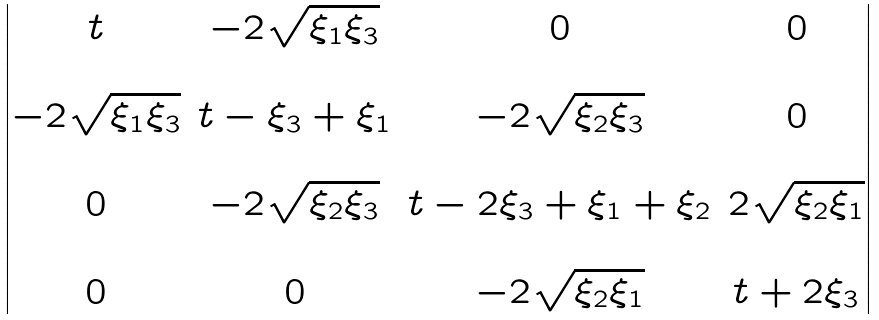<formula> <loc_0><loc_0><loc_500><loc_500>\begin{vmatrix} t & - 2 \sqrt { \xi _ { 1 } \xi _ { 3 } } & 0 & 0 \\ & & & \\ - 2 \sqrt { \xi _ { 1 } \xi _ { 3 } } & t - \xi _ { 3 } + \xi _ { 1 } & - 2 \sqrt { \xi _ { 2 } \xi _ { 3 } } & 0 \\ & & & \\ 0 & - 2 \sqrt { \xi _ { 2 } \xi _ { 3 } } & t - 2 \xi _ { 3 } + \xi _ { 1 } + \xi _ { 2 } & 2 \sqrt { \xi _ { 2 } \xi _ { 1 } } \\ & & & \\ 0 & 0 & - 2 \sqrt { \xi _ { 2 } \xi _ { 1 } } & t + 2 \xi _ { 3 } \end{vmatrix}</formula> 